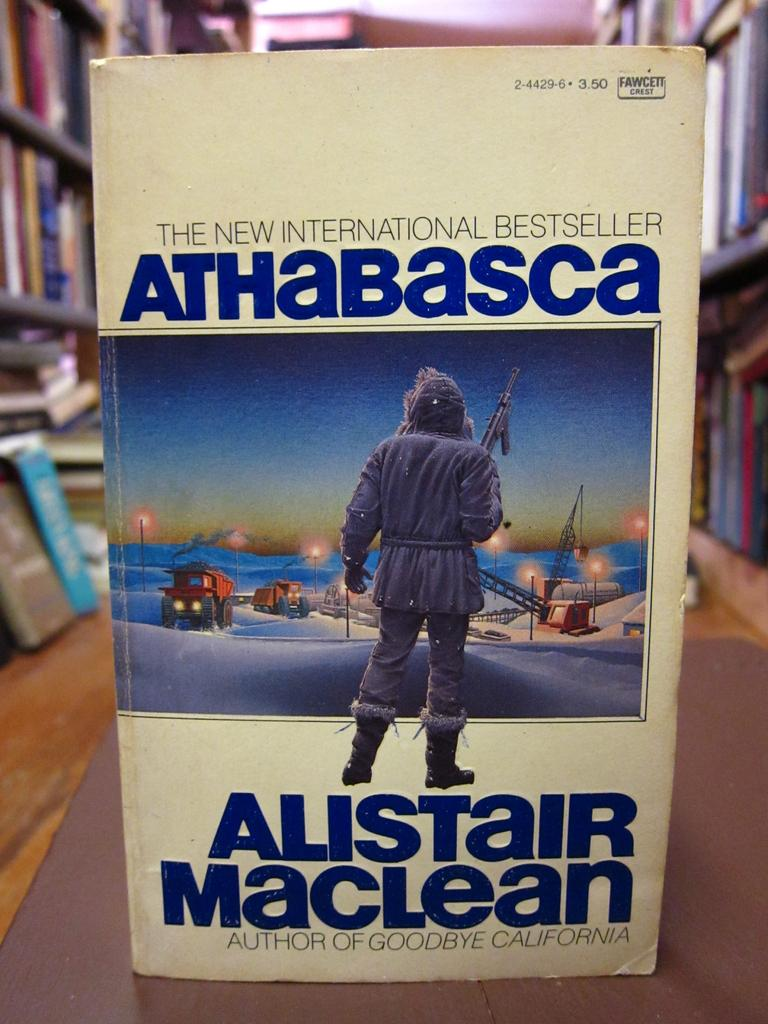<image>
Give a short and clear explanation of the subsequent image. A book with a cream cover reading The New International Bestseller. 